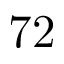<formula> <loc_0><loc_0><loc_500><loc_500>7 2</formula> 